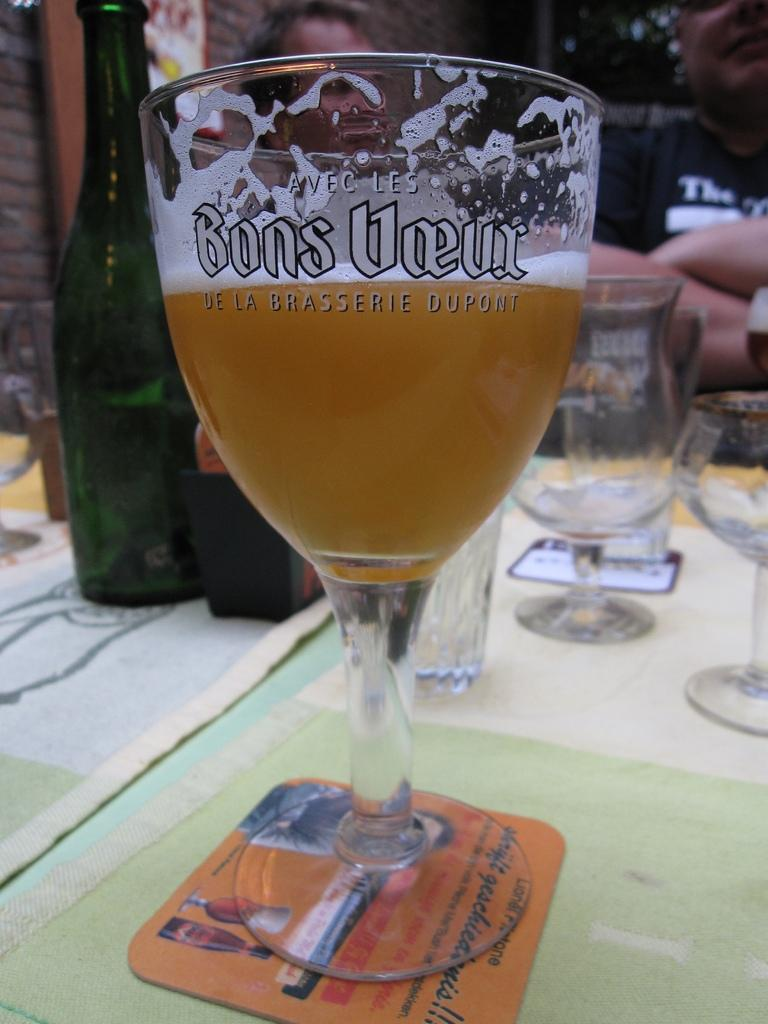<image>
Render a clear and concise summary of the photo. A glass with a coaster that says Bons Voeur. 